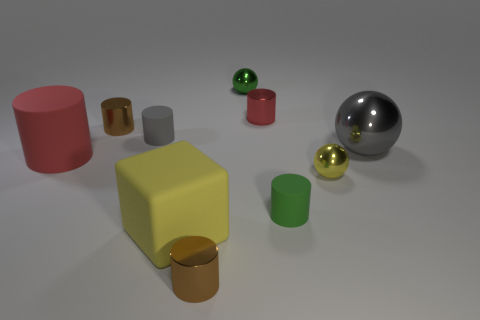Subtract all gray cylinders. How many cylinders are left? 5 Subtract all green cylinders. How many cylinders are left? 5 Subtract all blue cylinders. Subtract all cyan blocks. How many cylinders are left? 6 Subtract all cubes. How many objects are left? 9 Subtract 0 purple cylinders. How many objects are left? 10 Subtract all tiny yellow spheres. Subtract all gray things. How many objects are left? 7 Add 6 small rubber cylinders. How many small rubber cylinders are left? 8 Add 3 large cyan spheres. How many large cyan spheres exist? 3 